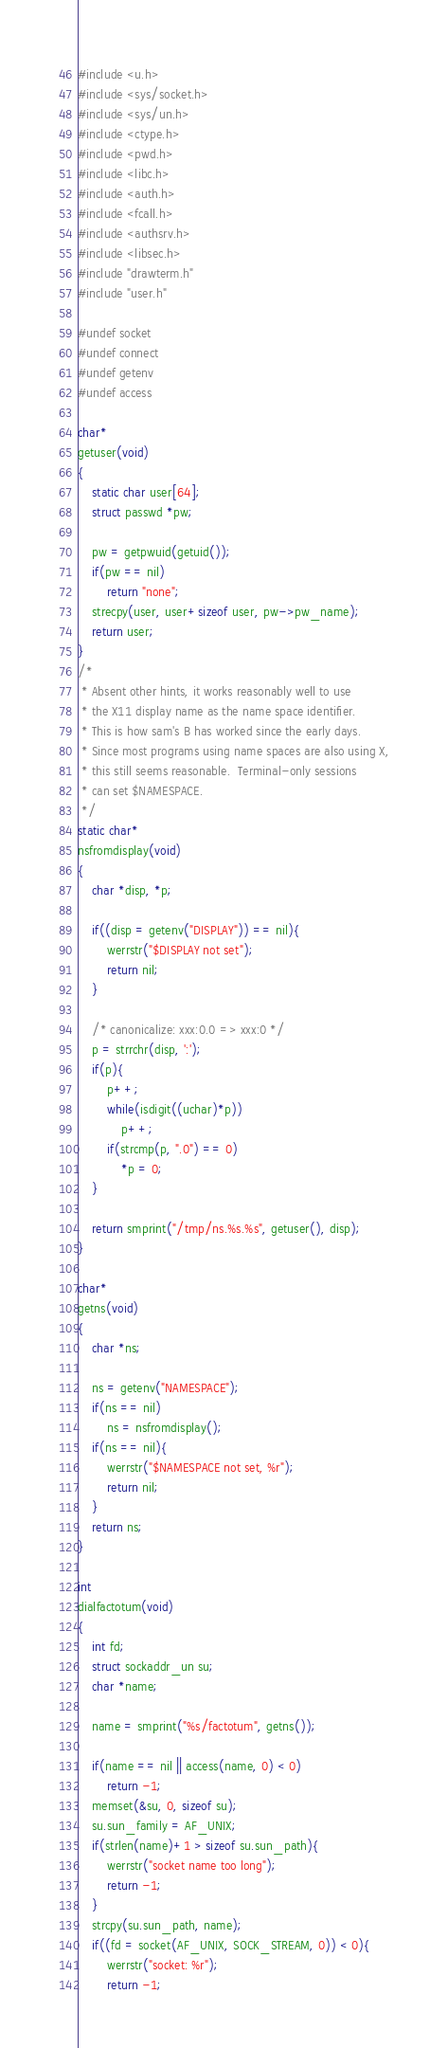<code> <loc_0><loc_0><loc_500><loc_500><_C_>#include <u.h>
#include <sys/socket.h>
#include <sys/un.h>
#include <ctype.h>
#include <pwd.h>
#include <libc.h>
#include <auth.h>
#include <fcall.h>
#include <authsrv.h>
#include <libsec.h>
#include "drawterm.h"
#include "user.h"

#undef socket
#undef connect
#undef getenv
#undef access

char*
getuser(void)
{
	static char user[64];
	struct passwd *pw;

	pw = getpwuid(getuid());
	if(pw == nil)
		return "none";
	strecpy(user, user+sizeof user, pw->pw_name);
	return user;
}
/*
 * Absent other hints, it works reasonably well to use
 * the X11 display name as the name space identifier.
 * This is how sam's B has worked since the early days.
 * Since most programs using name spaces are also using X,
 * this still seems reasonable.  Terminal-only sessions
 * can set $NAMESPACE.
 */
static char*
nsfromdisplay(void)
{
	char *disp, *p;

	if((disp = getenv("DISPLAY")) == nil){
		werrstr("$DISPLAY not set");
		return nil;
	}

	/* canonicalize: xxx:0.0 => xxx:0 */
	p = strrchr(disp, ':');
	if(p){
		p++;
		while(isdigit((uchar)*p))
			p++;
		if(strcmp(p, ".0") == 0)
			*p = 0;
	}

	return smprint("/tmp/ns.%s.%s", getuser(), disp);
}

char*
getns(void)
{
	char *ns;

	ns = getenv("NAMESPACE");
	if(ns == nil)
		ns = nsfromdisplay();
	if(ns == nil){
		werrstr("$NAMESPACE not set, %r");
		return nil;
	}
	return ns;
}

int
dialfactotum(void)
{
	int fd;
	struct sockaddr_un su;
	char *name;
	
	name = smprint("%s/factotum", getns());

	if(name == nil || access(name, 0) < 0)
		return -1;
	memset(&su, 0, sizeof su);
	su.sun_family = AF_UNIX;
	if(strlen(name)+1 > sizeof su.sun_path){
		werrstr("socket name too long");
		return -1;
	}
	strcpy(su.sun_path, name);
	if((fd = socket(AF_UNIX, SOCK_STREAM, 0)) < 0){
		werrstr("socket: %r");
		return -1;</code> 